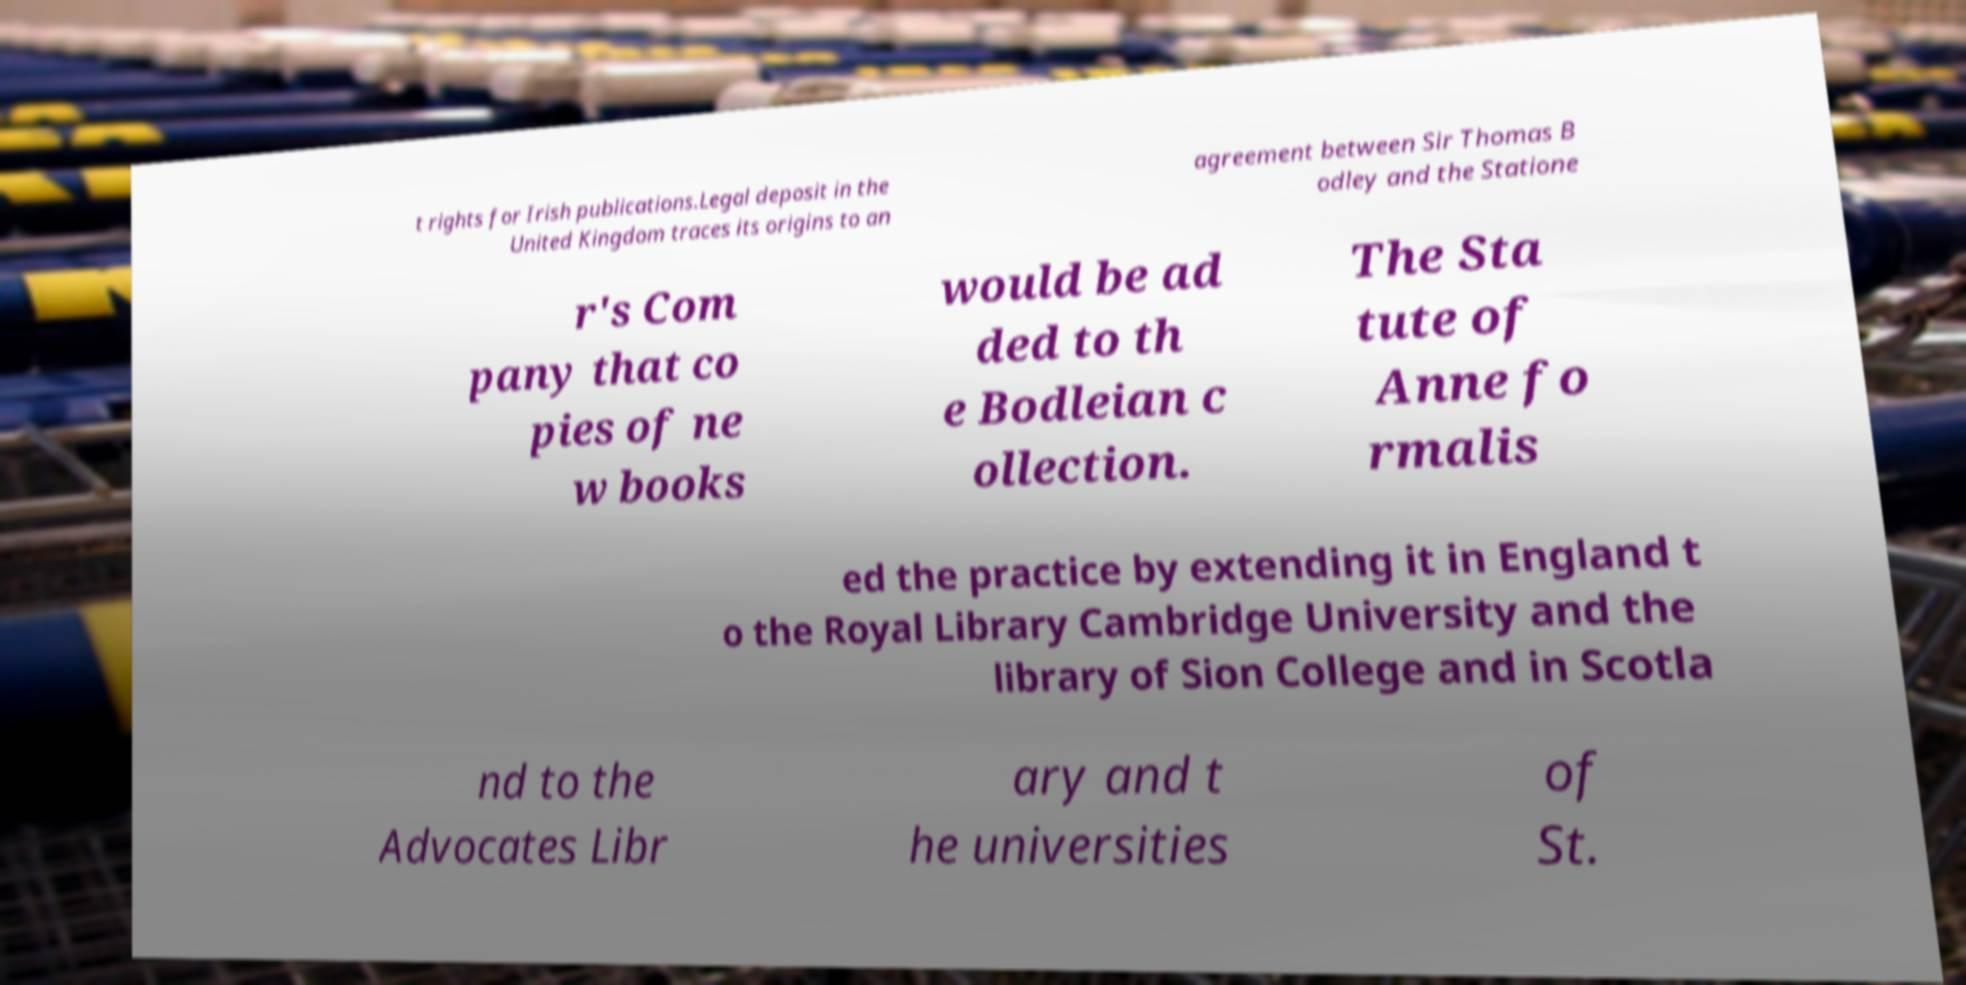For documentation purposes, I need the text within this image transcribed. Could you provide that? t rights for Irish publications.Legal deposit in the United Kingdom traces its origins to an agreement between Sir Thomas B odley and the Statione r's Com pany that co pies of ne w books would be ad ded to th e Bodleian c ollection. The Sta tute of Anne fo rmalis ed the practice by extending it in England t o the Royal Library Cambridge University and the library of Sion College and in Scotla nd to the Advocates Libr ary and t he universities of St. 